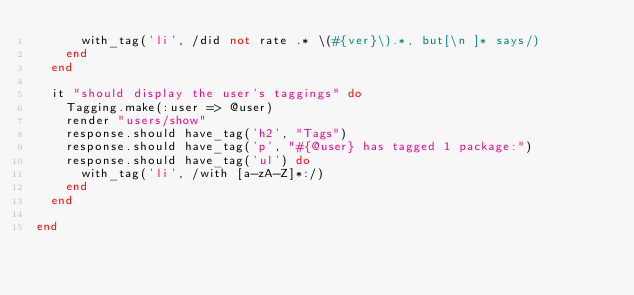<code> <loc_0><loc_0><loc_500><loc_500><_Ruby_>      with_tag('li', /did not rate .* \(#{ver}\).*, but[\n ]* says/)
    end
  end

  it "should display the user's taggings" do
    Tagging.make(:user => @user)
    render "users/show"
    response.should have_tag('h2', "Tags")
    response.should have_tag('p', "#{@user} has tagged 1 package:")
    response.should have_tag('ul') do
      with_tag('li', /with [a-zA-Z]*:/)
    end
  end

end
</code> 